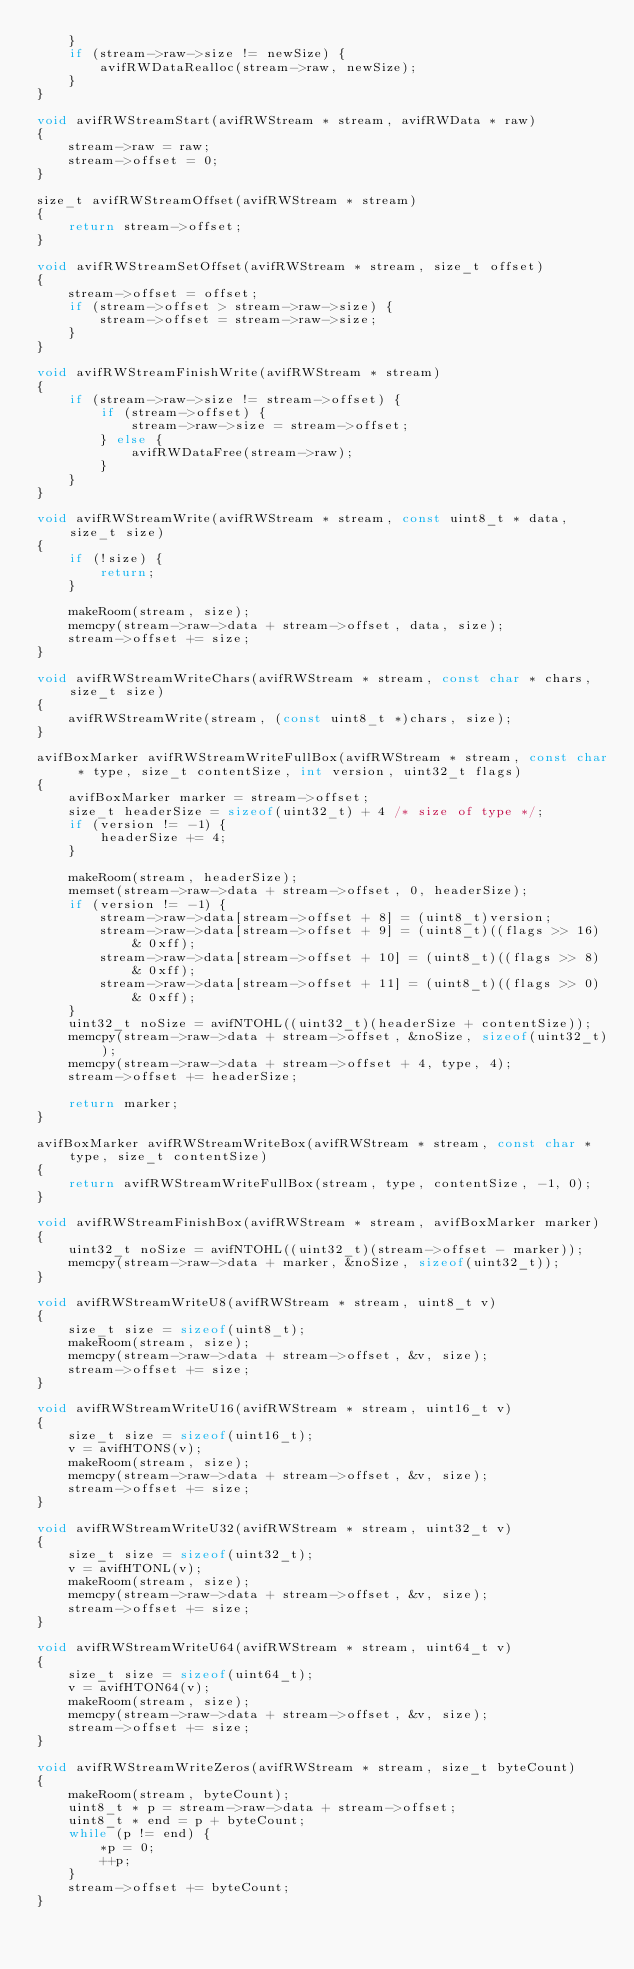<code> <loc_0><loc_0><loc_500><loc_500><_C_>    }
    if (stream->raw->size != newSize) {
        avifRWDataRealloc(stream->raw, newSize);
    }
}

void avifRWStreamStart(avifRWStream * stream, avifRWData * raw)
{
    stream->raw = raw;
    stream->offset = 0;
}

size_t avifRWStreamOffset(avifRWStream * stream)
{
    return stream->offset;
}

void avifRWStreamSetOffset(avifRWStream * stream, size_t offset)
{
    stream->offset = offset;
    if (stream->offset > stream->raw->size) {
        stream->offset = stream->raw->size;
    }
}

void avifRWStreamFinishWrite(avifRWStream * stream)
{
    if (stream->raw->size != stream->offset) {
        if (stream->offset) {
            stream->raw->size = stream->offset;
        } else {
            avifRWDataFree(stream->raw);
        }
    }
}

void avifRWStreamWrite(avifRWStream * stream, const uint8_t * data, size_t size)
{
    if (!size) {
        return;
    }

    makeRoom(stream, size);
    memcpy(stream->raw->data + stream->offset, data, size);
    stream->offset += size;
}

void avifRWStreamWriteChars(avifRWStream * stream, const char * chars, size_t size)
{
    avifRWStreamWrite(stream, (const uint8_t *)chars, size);
}

avifBoxMarker avifRWStreamWriteFullBox(avifRWStream * stream, const char * type, size_t contentSize, int version, uint32_t flags)
{
    avifBoxMarker marker = stream->offset;
    size_t headerSize = sizeof(uint32_t) + 4 /* size of type */;
    if (version != -1) {
        headerSize += 4;
    }

    makeRoom(stream, headerSize);
    memset(stream->raw->data + stream->offset, 0, headerSize);
    if (version != -1) {
        stream->raw->data[stream->offset + 8] = (uint8_t)version;
        stream->raw->data[stream->offset + 9] = (uint8_t)((flags >> 16) & 0xff);
        stream->raw->data[stream->offset + 10] = (uint8_t)((flags >> 8) & 0xff);
        stream->raw->data[stream->offset + 11] = (uint8_t)((flags >> 0) & 0xff);
    }
    uint32_t noSize = avifNTOHL((uint32_t)(headerSize + contentSize));
    memcpy(stream->raw->data + stream->offset, &noSize, sizeof(uint32_t));
    memcpy(stream->raw->data + stream->offset + 4, type, 4);
    stream->offset += headerSize;

    return marker;
}

avifBoxMarker avifRWStreamWriteBox(avifRWStream * stream, const char * type, size_t contentSize)
{
    return avifRWStreamWriteFullBox(stream, type, contentSize, -1, 0);
}

void avifRWStreamFinishBox(avifRWStream * stream, avifBoxMarker marker)
{
    uint32_t noSize = avifNTOHL((uint32_t)(stream->offset - marker));
    memcpy(stream->raw->data + marker, &noSize, sizeof(uint32_t));
}

void avifRWStreamWriteU8(avifRWStream * stream, uint8_t v)
{
    size_t size = sizeof(uint8_t);
    makeRoom(stream, size);
    memcpy(stream->raw->data + stream->offset, &v, size);
    stream->offset += size;
}

void avifRWStreamWriteU16(avifRWStream * stream, uint16_t v)
{
    size_t size = sizeof(uint16_t);
    v = avifHTONS(v);
    makeRoom(stream, size);
    memcpy(stream->raw->data + stream->offset, &v, size);
    stream->offset += size;
}

void avifRWStreamWriteU32(avifRWStream * stream, uint32_t v)
{
    size_t size = sizeof(uint32_t);
    v = avifHTONL(v);
    makeRoom(stream, size);
    memcpy(stream->raw->data + stream->offset, &v, size);
    stream->offset += size;
}

void avifRWStreamWriteU64(avifRWStream * stream, uint64_t v)
{
    size_t size = sizeof(uint64_t);
    v = avifHTON64(v);
    makeRoom(stream, size);
    memcpy(stream->raw->data + stream->offset, &v, size);
    stream->offset += size;
}

void avifRWStreamWriteZeros(avifRWStream * stream, size_t byteCount)
{
    makeRoom(stream, byteCount);
    uint8_t * p = stream->raw->data + stream->offset;
    uint8_t * end = p + byteCount;
    while (p != end) {
        *p = 0;
        ++p;
    }
    stream->offset += byteCount;
}
</code> 